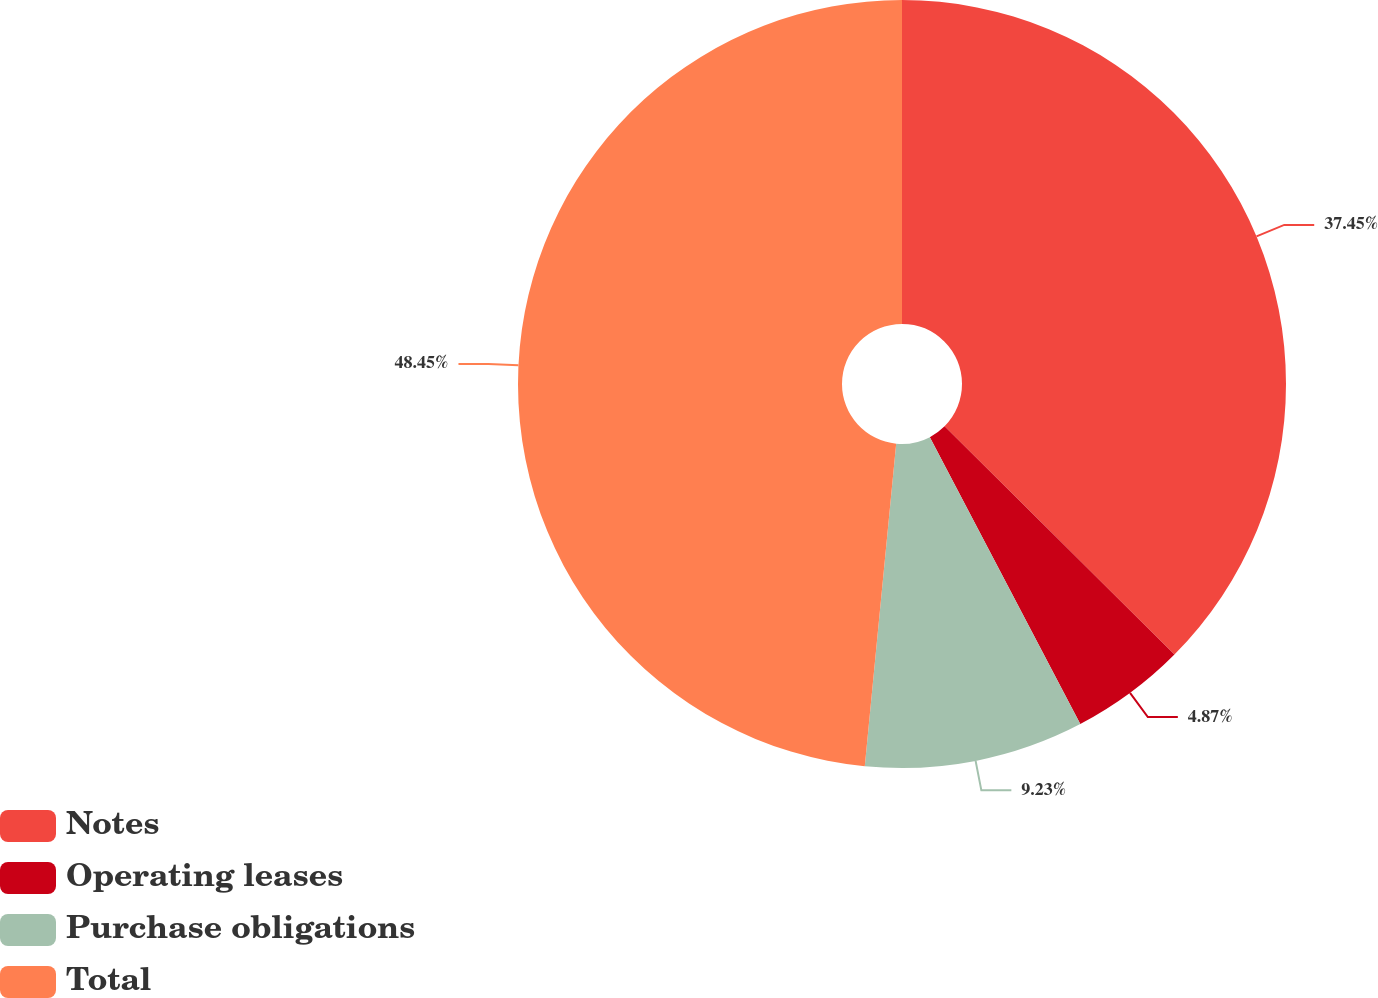<chart> <loc_0><loc_0><loc_500><loc_500><pie_chart><fcel>Notes<fcel>Operating leases<fcel>Purchase obligations<fcel>Total<nl><fcel>37.45%<fcel>4.87%<fcel>9.23%<fcel>48.46%<nl></chart> 